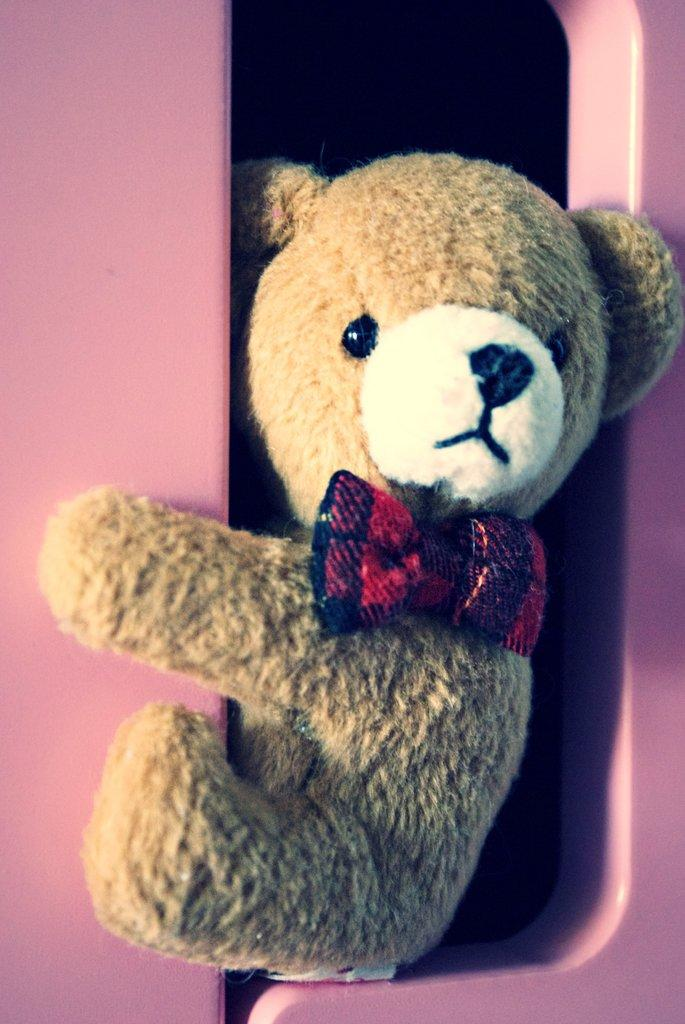What is the main object in the image? There is a letter block in the image. What is inside the letter block? There is a teddy bear in the letter block. What type of memory does the teddy bear have in the letter block? There is no indication in the image that the teddy bear has any memory, as it is an inanimate object. 